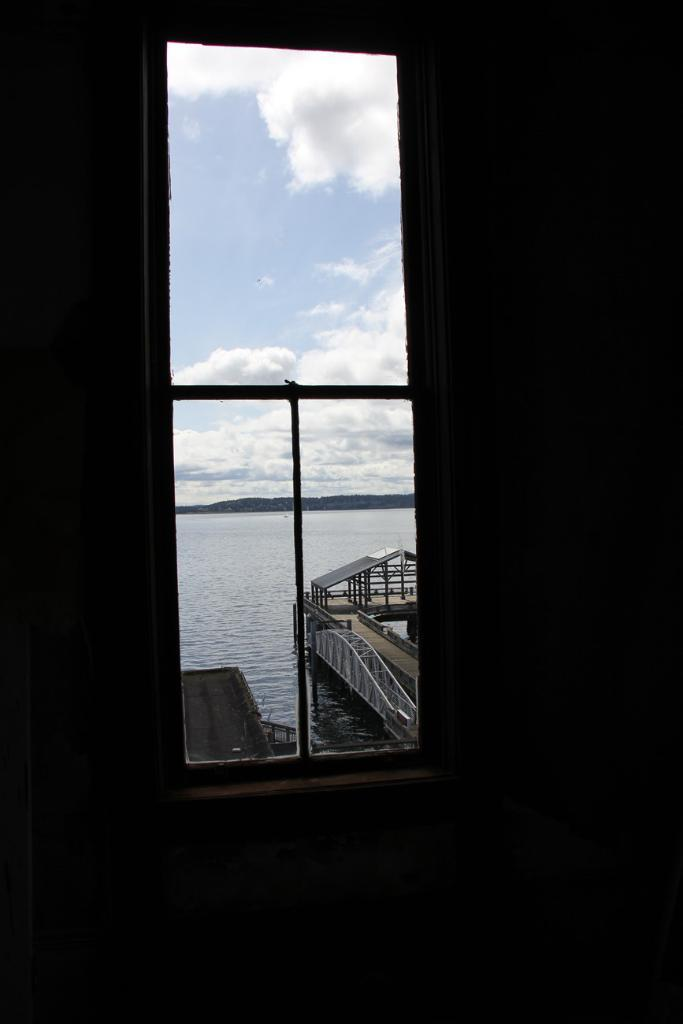What can be seen through the window in the picture? There is a bridge visible behind the window. Can you describe the location of the bridge in relation to the water? The bridge is above the water surface. What type of song is being sung by the hair in the image? There is no hair or song present in the image; it features a window with a bridge visible behind it. 